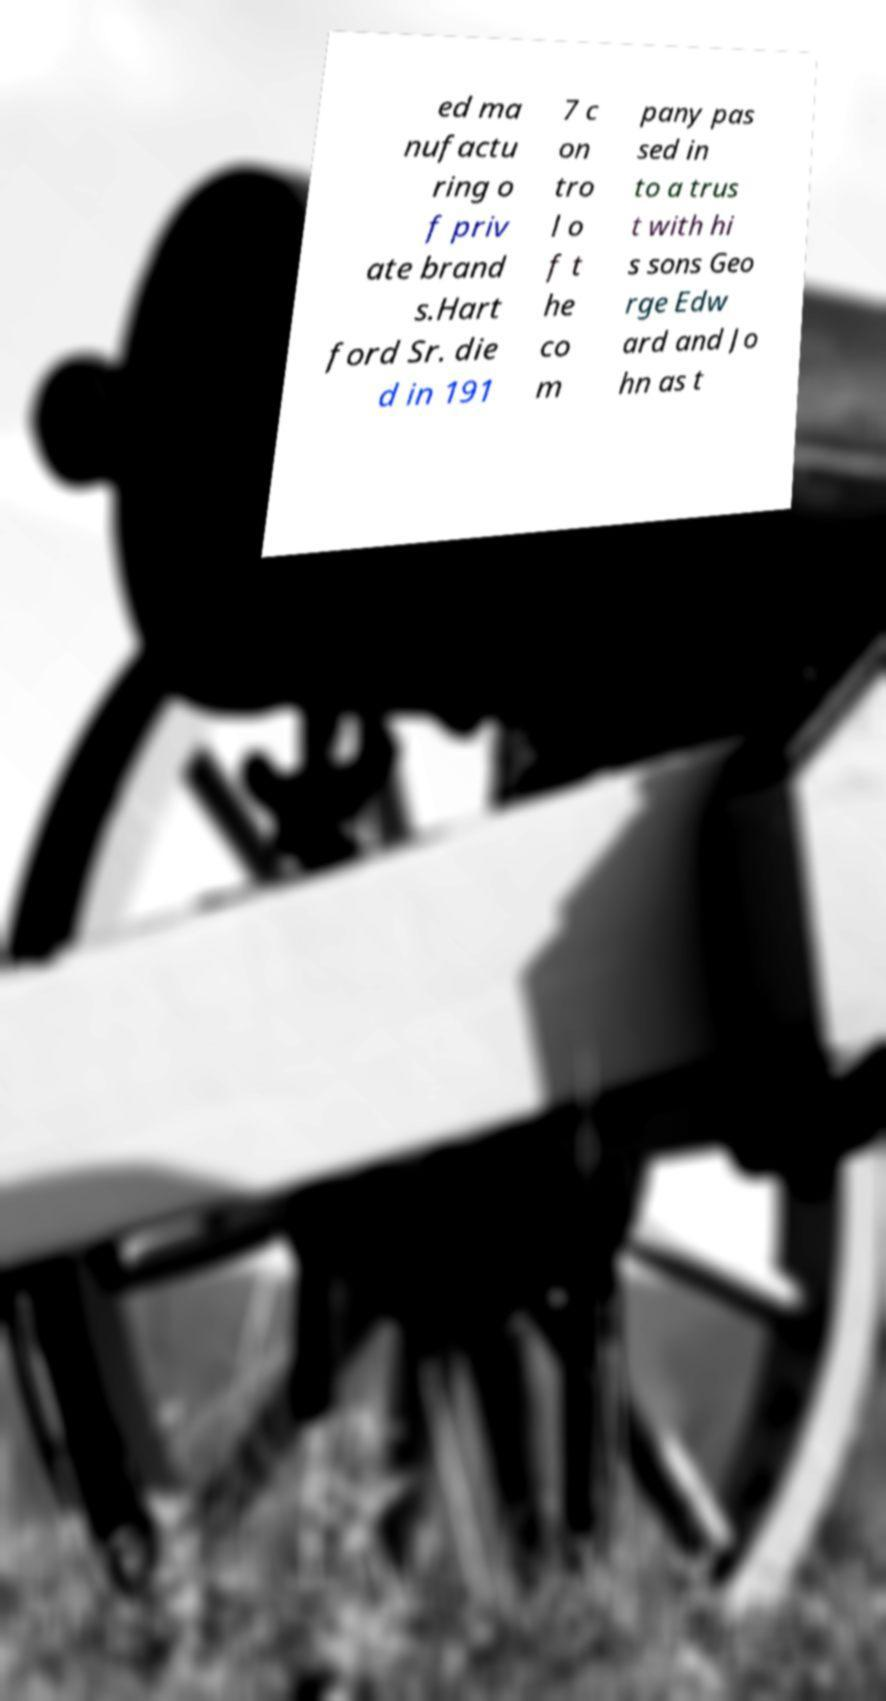I need the written content from this picture converted into text. Can you do that? ed ma nufactu ring o f priv ate brand s.Hart ford Sr. die d in 191 7 c on tro l o f t he co m pany pas sed in to a trus t with hi s sons Geo rge Edw ard and Jo hn as t 